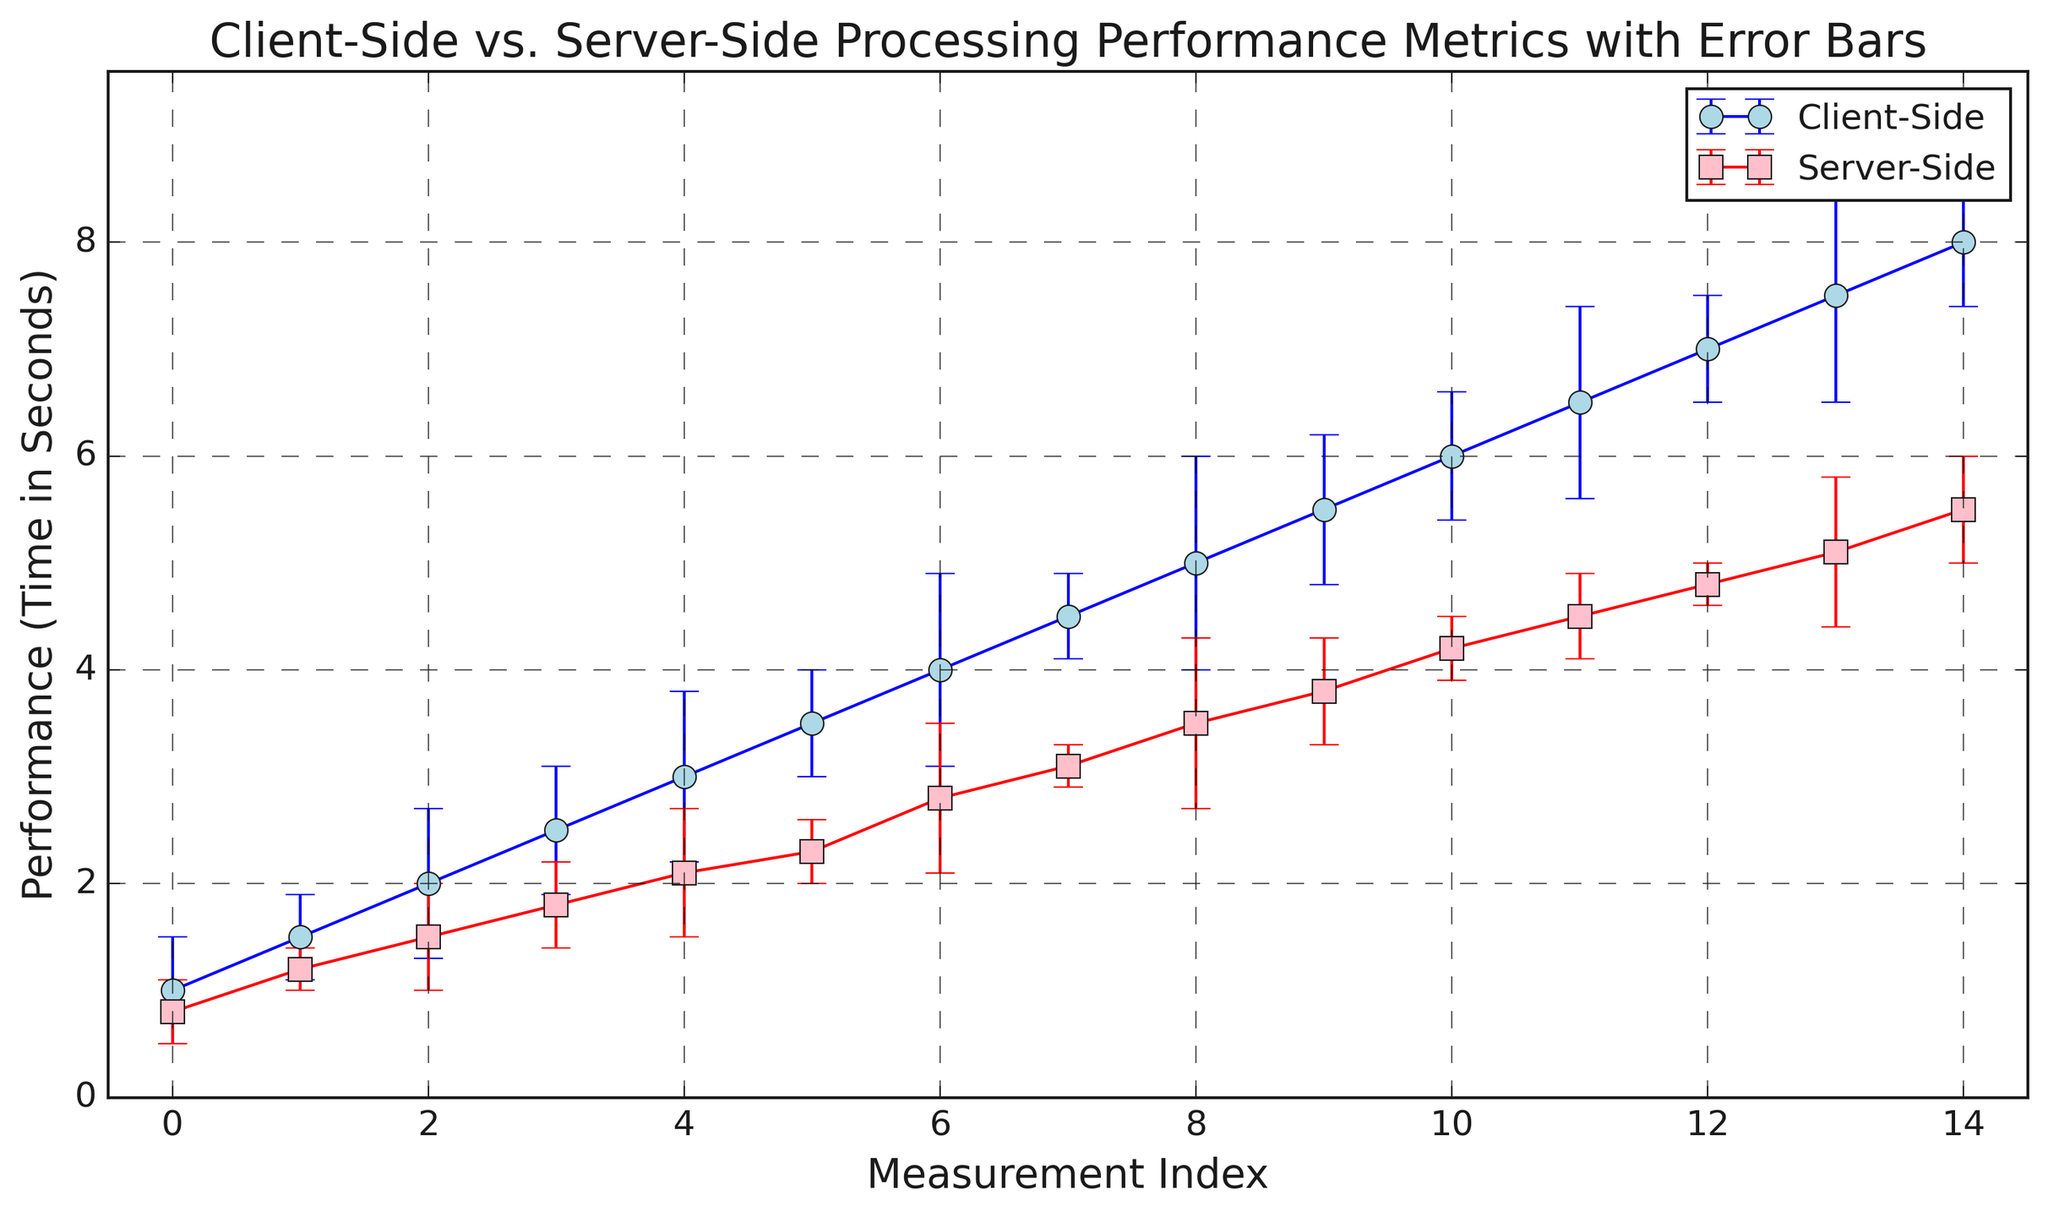What is the measurement index with the highest performance time for client-side processing? Look at the highest point of the blue curve (client-side processing) on the y-axis. It is located at the measurement index corresponding to 8.
Answer: 8 Which processing type has the lower performance time at measurement index 5? Compare the two processing times at measurement index 5. The client-side time is 3.0 seconds, and the server-side time is 2.1 seconds.
Answer: Server-Side What is the difference between client-side and server-side performance times at measurement index 10? At index 10, client-side performance time is 5.0 seconds, and server-side is 3.5 seconds. The difference is 5.0 - 3.5.
Answer: 1.5 Which processing type shows more variability in performance times? Analyze the size of the error bars from both lines. The client-side error bars (blue) are generally larger than the server-side error bars (red).
Answer: Client-Side At which measurement index do the client-side and server-side performance times differ the most? Calculate the differences at each index and find the one with the largest absolute difference. The biggest difference appears at index 15, with client-side at 8.0 seconds and server-side at 5.5 seconds, so the difference is 2.5 seconds.
Answer: 15 How does the performance of server-side processing change from measurement index 3 to 6? Refer to the red curve from index 3 to 6. The performance time increases from 1.8 seconds to 4.2 seconds. This means it increased by 4.2 - 1.8 seconds.
Answer: 2.4 What is the average error margin of client-side processing across all measurement indices? Sum up all the error values for client-side, which are 0.5, 0.4, 0.7, 0.6, 0.8, 0.5, 0.9, 0.4, 1.0, 0.7, 0.6, 0.9, 0.5, 1.0, 0.6 and divide by the number of indices (15). The total error sum is 12.5, so the average error is 12.5/15.
Answer: 0.83 